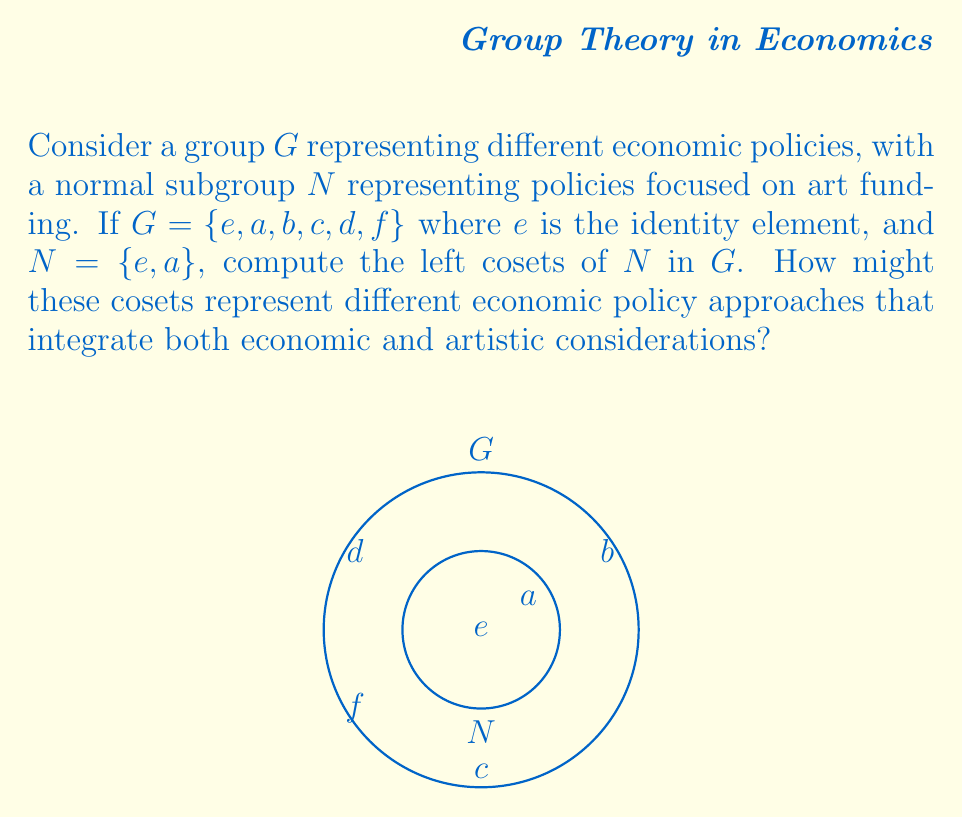Give your solution to this math problem. To compute the left cosets of $N$ in $G$, we need to multiply each element of $G$ by $N$ from the left. The steps are as follows:

1) First, recall that for a subgroup $N$ of $G$, the left coset of $N$ with respect to an element $g \in G$ is defined as $gN = \{gn : n \in N\}$.

2) We need to compute $gN$ for each $g \in G$:

   $eN = \{en : n \in N\} = \{e, a\}$
   $aN = \{an : n \in N\} = \{a, e\}$ (since $a^2 = e$ in this group)
   $bN = \{bn : n \in N\} = \{b, ba\}$
   $cN = \{cn : n \in N\} = \{c, ca\}$
   $dN = \{dn : n \in N\} = \{d, da\}$
   $fN = \{fn : n \in N\} = \{f, fa\}$

3) We observe that $eN = aN = N$, and the other cosets are distinct.

4) Therefore, the distinct left cosets are:
   $N = \{e, a\}$
   $bN = \{b, ba\}$
   $cN = \{c, ca\}$
   $dN = \{d, da\}$
   $fN = \{f, fa\}$

5) In the context of economic policies, these cosets could represent different policy approaches:
   - $N$ might represent policies purely focused on art funding.
   - $bN, cN, dN,$ and $fN$ could represent policies that combine art funding with other economic considerations (e.g., fiscal policy, monetary policy, trade policy, and labor policy).

This grouping demonstrates how art-focused policies can be integrated with various economic approaches, reflecting the interplay between economics and art in shaping historical events.
Answer: The left cosets of $N$ in $G$ are $N = \{e, a\}$, $bN = \{b, ba\}$, $cN = \{c, ca\}$, $dN = \{d, da\}$, and $fN = \{f, fa\}$. 